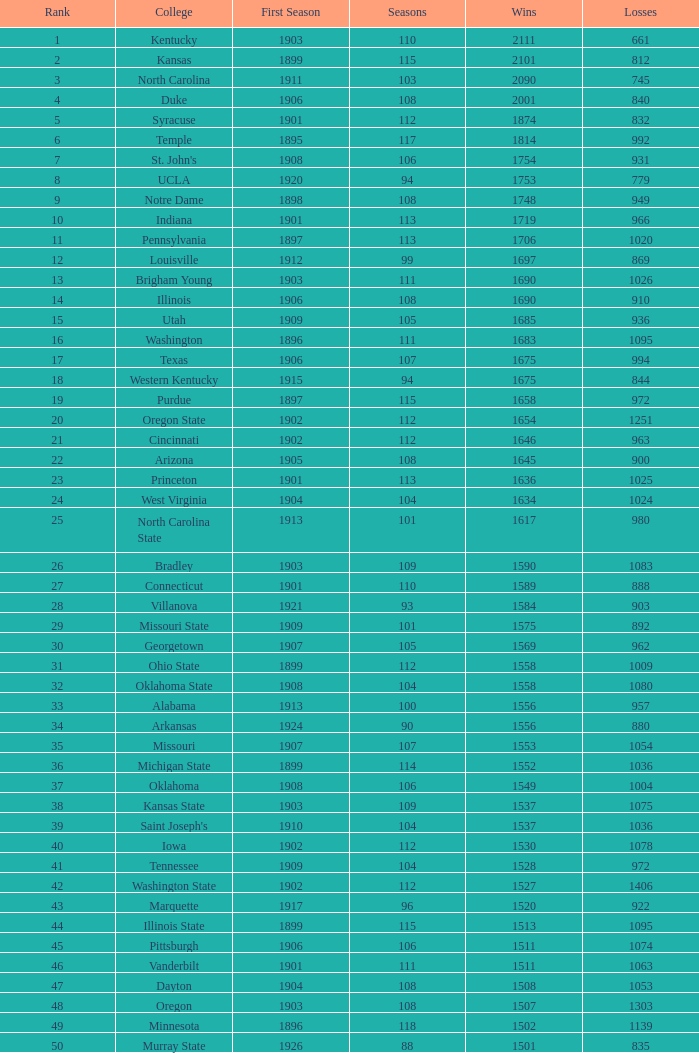How many successful outcomes were there for washington state college with in excess of 980 setbacks, a starting season preceding 1906, and a position greater than 42? 0.0. Could you help me parse every detail presented in this table? {'header': ['Rank', 'College', 'First Season', 'Seasons', 'Wins', 'Losses'], 'rows': [['1', 'Kentucky', '1903', '110', '2111', '661'], ['2', 'Kansas', '1899', '115', '2101', '812'], ['3', 'North Carolina', '1911', '103', '2090', '745'], ['4', 'Duke', '1906', '108', '2001', '840'], ['5', 'Syracuse', '1901', '112', '1874', '832'], ['6', 'Temple', '1895', '117', '1814', '992'], ['7', "St. John's", '1908', '106', '1754', '931'], ['8', 'UCLA', '1920', '94', '1753', '779'], ['9', 'Notre Dame', '1898', '108', '1748', '949'], ['10', 'Indiana', '1901', '113', '1719', '966'], ['11', 'Pennsylvania', '1897', '113', '1706', '1020'], ['12', 'Louisville', '1912', '99', '1697', '869'], ['13', 'Brigham Young', '1903', '111', '1690', '1026'], ['14', 'Illinois', '1906', '108', '1690', '910'], ['15', 'Utah', '1909', '105', '1685', '936'], ['16', 'Washington', '1896', '111', '1683', '1095'], ['17', 'Texas', '1906', '107', '1675', '994'], ['18', 'Western Kentucky', '1915', '94', '1675', '844'], ['19', 'Purdue', '1897', '115', '1658', '972'], ['20', 'Oregon State', '1902', '112', '1654', '1251'], ['21', 'Cincinnati', '1902', '112', '1646', '963'], ['22', 'Arizona', '1905', '108', '1645', '900'], ['23', 'Princeton', '1901', '113', '1636', '1025'], ['24', 'West Virginia', '1904', '104', '1634', '1024'], ['25', 'North Carolina State', '1913', '101', '1617', '980'], ['26', 'Bradley', '1903', '109', '1590', '1083'], ['27', 'Connecticut', '1901', '110', '1589', '888'], ['28', 'Villanova', '1921', '93', '1584', '903'], ['29', 'Missouri State', '1909', '101', '1575', '892'], ['30', 'Georgetown', '1907', '105', '1569', '962'], ['31', 'Ohio State', '1899', '112', '1558', '1009'], ['32', 'Oklahoma State', '1908', '104', '1558', '1080'], ['33', 'Alabama', '1913', '100', '1556', '957'], ['34', 'Arkansas', '1924', '90', '1556', '880'], ['35', 'Missouri', '1907', '107', '1553', '1054'], ['36', 'Michigan State', '1899', '114', '1552', '1036'], ['37', 'Oklahoma', '1908', '106', '1549', '1004'], ['38', 'Kansas State', '1903', '109', '1537', '1075'], ['39', "Saint Joseph's", '1910', '104', '1537', '1036'], ['40', 'Iowa', '1902', '112', '1530', '1078'], ['41', 'Tennessee', '1909', '104', '1528', '972'], ['42', 'Washington State', '1902', '112', '1527', '1406'], ['43', 'Marquette', '1917', '96', '1520', '922'], ['44', 'Illinois State', '1899', '115', '1513', '1095'], ['45', 'Pittsburgh', '1906', '106', '1511', '1074'], ['46', 'Vanderbilt', '1901', '111', '1511', '1063'], ['47', 'Dayton', '1904', '108', '1508', '1053'], ['48', 'Oregon', '1903', '108', '1507', '1303'], ['49', 'Minnesota', '1896', '118', '1502', '1139'], ['50', 'Murray State', '1926', '88', '1501', '835']]} 